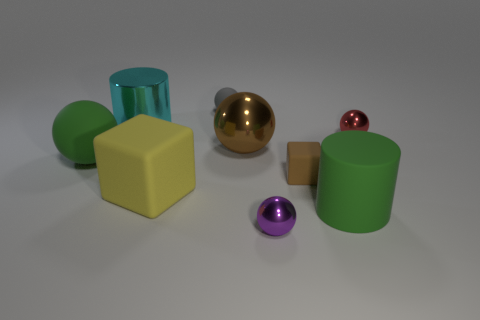Can you describe the lighting in this scene? The lighting in the scene is diffused and soft, seemingly coming from above, as indicated by the subtle shadows under the objects. The lack of sharp shadows suggests an overcast sky or an indirect light source. This kind of lighting reduces the contrast and provides a clarity that enhances the visibility of shapes and colors in the composition. 